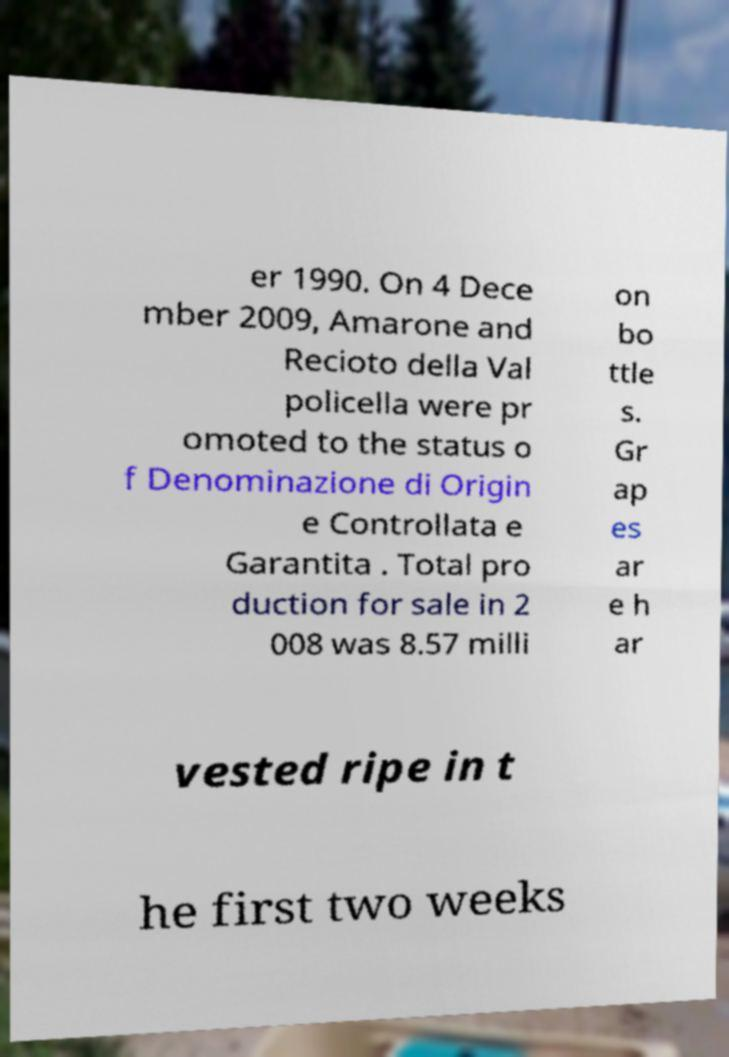I need the written content from this picture converted into text. Can you do that? er 1990. On 4 Dece mber 2009, Amarone and Recioto della Val policella were pr omoted to the status o f Denominazione di Origin e Controllata e Garantita . Total pro duction for sale in 2 008 was 8.57 milli on bo ttle s. Gr ap es ar e h ar vested ripe in t he first two weeks 